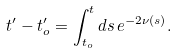Convert formula to latex. <formula><loc_0><loc_0><loc_500><loc_500>t ^ { \prime } - t _ { o } ^ { \prime } = \int _ { t _ { o } } ^ { t } d s \, e ^ { - 2 \nu ( s ) } .</formula> 